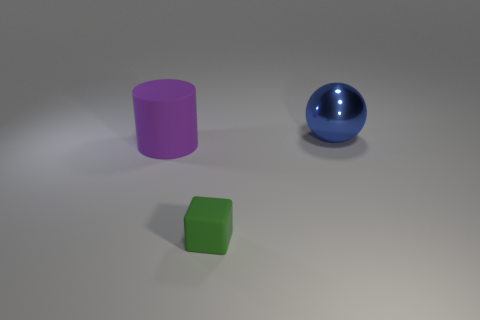Add 3 large blue metal balls. How many objects exist? 6 Subtract all balls. How many objects are left? 2 Subtract all small purple blocks. Subtract all spheres. How many objects are left? 2 Add 3 tiny green blocks. How many tiny green blocks are left? 4 Add 1 small brown rubber things. How many small brown rubber things exist? 1 Subtract 0 yellow cylinders. How many objects are left? 3 